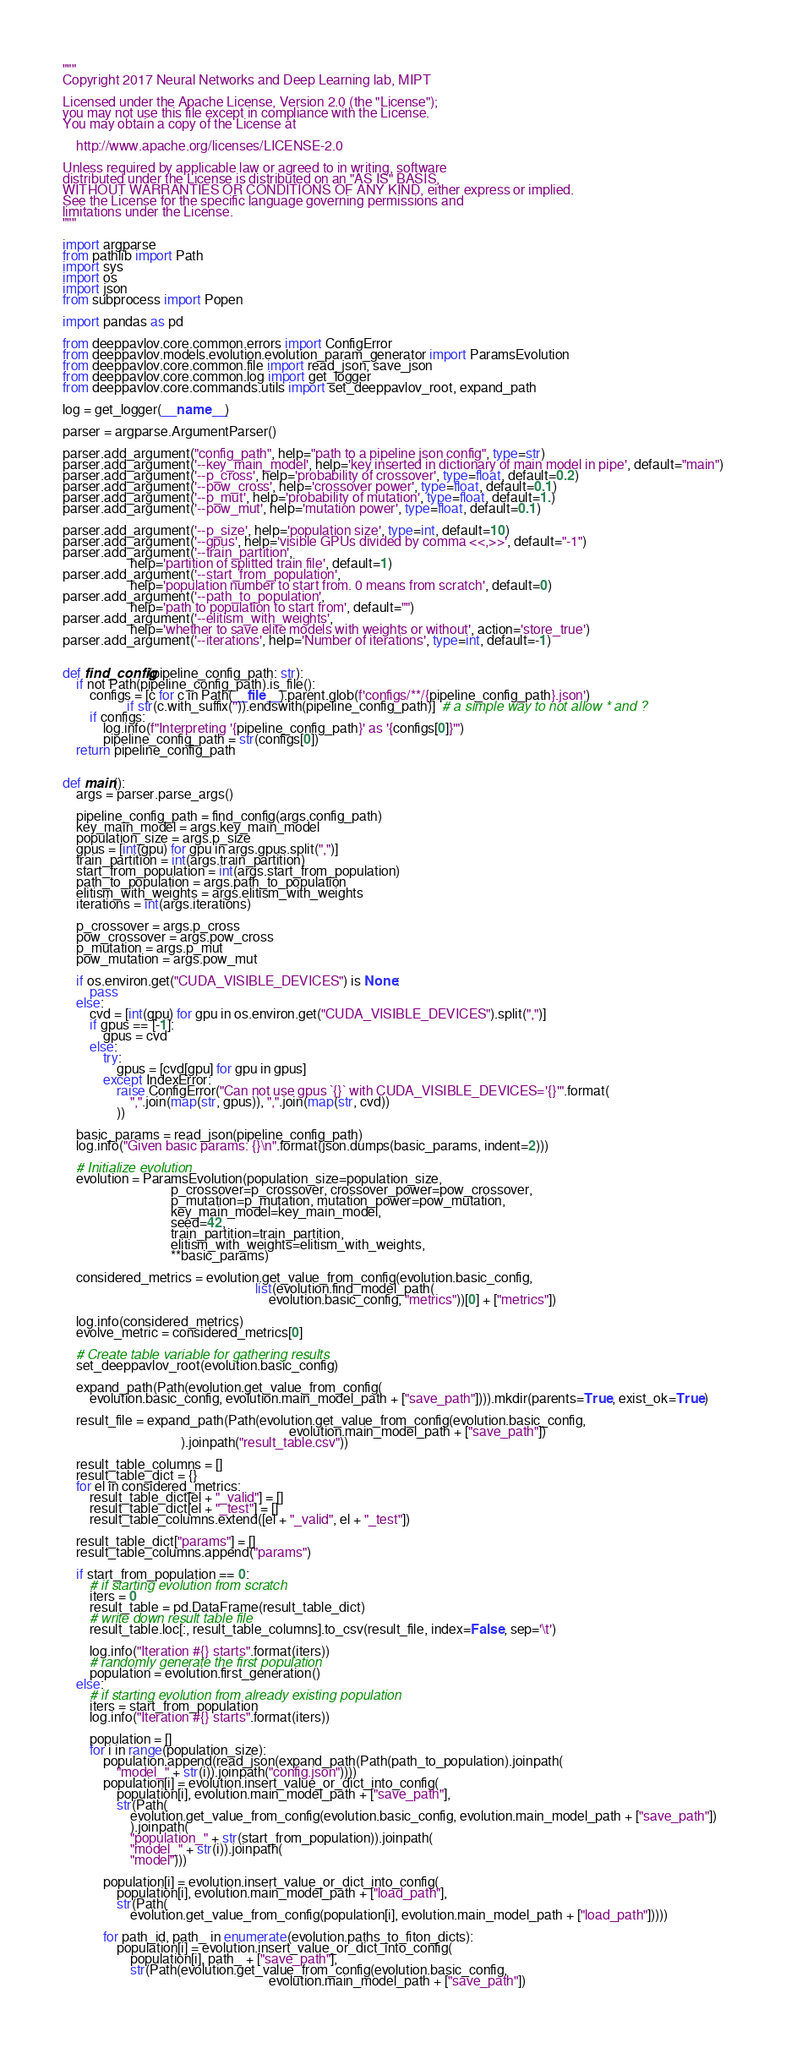<code> <loc_0><loc_0><loc_500><loc_500><_Python_>"""
Copyright 2017 Neural Networks and Deep Learning lab, MIPT

Licensed under the Apache License, Version 2.0 (the "License");
you may not use this file except in compliance with the License.
You may obtain a copy of the License at

    http://www.apache.org/licenses/LICENSE-2.0

Unless required by applicable law or agreed to in writing, software
distributed under the License is distributed on an "AS IS" BASIS,
WITHOUT WARRANTIES OR CONDITIONS OF ANY KIND, either express or implied.
See the License for the specific language governing permissions and
limitations under the License.
"""

import argparse
from pathlib import Path
import sys
import os
import json
from subprocess import Popen

import pandas as pd

from deeppavlov.core.common.errors import ConfigError
from deeppavlov.models.evolution.evolution_param_generator import ParamsEvolution
from deeppavlov.core.common.file import read_json, save_json
from deeppavlov.core.common.log import get_logger
from deeppavlov.core.commands.utils import set_deeppavlov_root, expand_path

log = get_logger(__name__)

parser = argparse.ArgumentParser()

parser.add_argument("config_path", help="path to a pipeline json config", type=str)
parser.add_argument('--key_main_model', help='key inserted in dictionary of main model in pipe', default="main")
parser.add_argument('--p_cross', help='probability of crossover', type=float, default=0.2)
parser.add_argument('--pow_cross', help='crossover power', type=float, default=0.1)
parser.add_argument('--p_mut', help='probability of mutation', type=float, default=1.)
parser.add_argument('--pow_mut', help='mutation power', type=float, default=0.1)

parser.add_argument('--p_size', help='population size', type=int, default=10)
parser.add_argument('--gpus', help='visible GPUs divided by comma <<,>>', default="-1")
parser.add_argument('--train_partition',
                    help='partition of splitted train file', default=1)
parser.add_argument('--start_from_population',
                    help='population number to start from. 0 means from scratch', default=0)
parser.add_argument('--path_to_population',
                    help='path to population to start from', default="")
parser.add_argument('--elitism_with_weights',
                    help='whether to save elite models with weights or without', action='store_true')
parser.add_argument('--iterations', help='Number of iterations', type=int, default=-1)


def find_config(pipeline_config_path: str):
    if not Path(pipeline_config_path).is_file():
        configs = [c for c in Path(__file__).parent.glob(f'configs/**/{pipeline_config_path}.json')
                   if str(c.with_suffix('')).endswith(pipeline_config_path)]  # a simple way to not allow * and ?
        if configs:
            log.info(f"Interpreting '{pipeline_config_path}' as '{configs[0]}'")
            pipeline_config_path = str(configs[0])
    return pipeline_config_path


def main():
    args = parser.parse_args()

    pipeline_config_path = find_config(args.config_path)
    key_main_model = args.key_main_model
    population_size = args.p_size
    gpus = [int(gpu) for gpu in args.gpus.split(",")]
    train_partition = int(args.train_partition)
    start_from_population = int(args.start_from_population)
    path_to_population = args.path_to_population
    elitism_with_weights = args.elitism_with_weights
    iterations = int(args.iterations)

    p_crossover = args.p_cross
    pow_crossover = args.pow_cross
    p_mutation = args.p_mut
    pow_mutation = args.pow_mut

    if os.environ.get("CUDA_VISIBLE_DEVICES") is None:
        pass
    else:
        cvd = [int(gpu) for gpu in os.environ.get("CUDA_VISIBLE_DEVICES").split(",")]
        if gpus == [-1]:
            gpus = cvd
        else:
            try:
                gpus = [cvd[gpu] for gpu in gpus]
            except IndexError:
                raise ConfigError("Can not use gpus `{}` with CUDA_VISIBLE_DEVICES='{}'".format(
                    ",".join(map(str, gpus)), ",".join(map(str, cvd))
                ))

    basic_params = read_json(pipeline_config_path)
    log.info("Given basic params: {}\n".format(json.dumps(basic_params, indent=2)))

    # Initialize evolution
    evolution = ParamsEvolution(population_size=population_size,
                                p_crossover=p_crossover, crossover_power=pow_crossover,
                                p_mutation=p_mutation, mutation_power=pow_mutation,
                                key_main_model=key_main_model,
                                seed=42,
                                train_partition=train_partition,
                                elitism_with_weights=elitism_with_weights,
                                **basic_params)

    considered_metrics = evolution.get_value_from_config(evolution.basic_config,
                                                         list(evolution.find_model_path(
                                                             evolution.basic_config, "metrics"))[0] + ["metrics"])

    log.info(considered_metrics)
    evolve_metric = considered_metrics[0]

    # Create table variable for gathering results
    set_deeppavlov_root(evolution.basic_config)

    expand_path(Path(evolution.get_value_from_config(
        evolution.basic_config, evolution.main_model_path + ["save_path"]))).mkdir(parents=True, exist_ok=True)

    result_file = expand_path(Path(evolution.get_value_from_config(evolution.basic_config,
                                                                   evolution.main_model_path + ["save_path"])
                                   ).joinpath("result_table.csv"))

    result_table_columns = []
    result_table_dict = {}
    for el in considered_metrics:
        result_table_dict[el + "_valid"] = []
        result_table_dict[el + "_test"] = []
        result_table_columns.extend([el + "_valid", el + "_test"])

    result_table_dict["params"] = []
    result_table_columns.append("params")

    if start_from_population == 0:
        # if starting evolution from scratch
        iters = 0
        result_table = pd.DataFrame(result_table_dict)
        # write down result table file
        result_table.loc[:, result_table_columns].to_csv(result_file, index=False, sep='\t')

        log.info("Iteration #{} starts".format(iters))
        # randomly generate the first population
        population = evolution.first_generation()
    else:
        # if starting evolution from already existing population
        iters = start_from_population
        log.info("Iteration #{} starts".format(iters))

        population = []
        for i in range(population_size):
            population.append(read_json(expand_path(Path(path_to_population).joinpath(
                "model_" + str(i)).joinpath("config.json"))))
            population[i] = evolution.insert_value_or_dict_into_config(
                population[i], evolution.main_model_path + ["save_path"],
                str(Path(
                    evolution.get_value_from_config(evolution.basic_config, evolution.main_model_path + ["save_path"])
                    ).joinpath(
                    "population_" + str(start_from_population)).joinpath(
                    "model_" + str(i)).joinpath(
                    "model")))

            population[i] = evolution.insert_value_or_dict_into_config(
                population[i], evolution.main_model_path + ["load_path"],
                str(Path(
                    evolution.get_value_from_config(population[i], evolution.main_model_path + ["load_path"]))))

            for path_id, path_ in enumerate(evolution.paths_to_fiton_dicts):
                population[i] = evolution.insert_value_or_dict_into_config(
                    population[i], path_ + ["save_path"],
                    str(Path(evolution.get_value_from_config(evolution.basic_config,
                                                             evolution.main_model_path + ["save_path"])</code> 